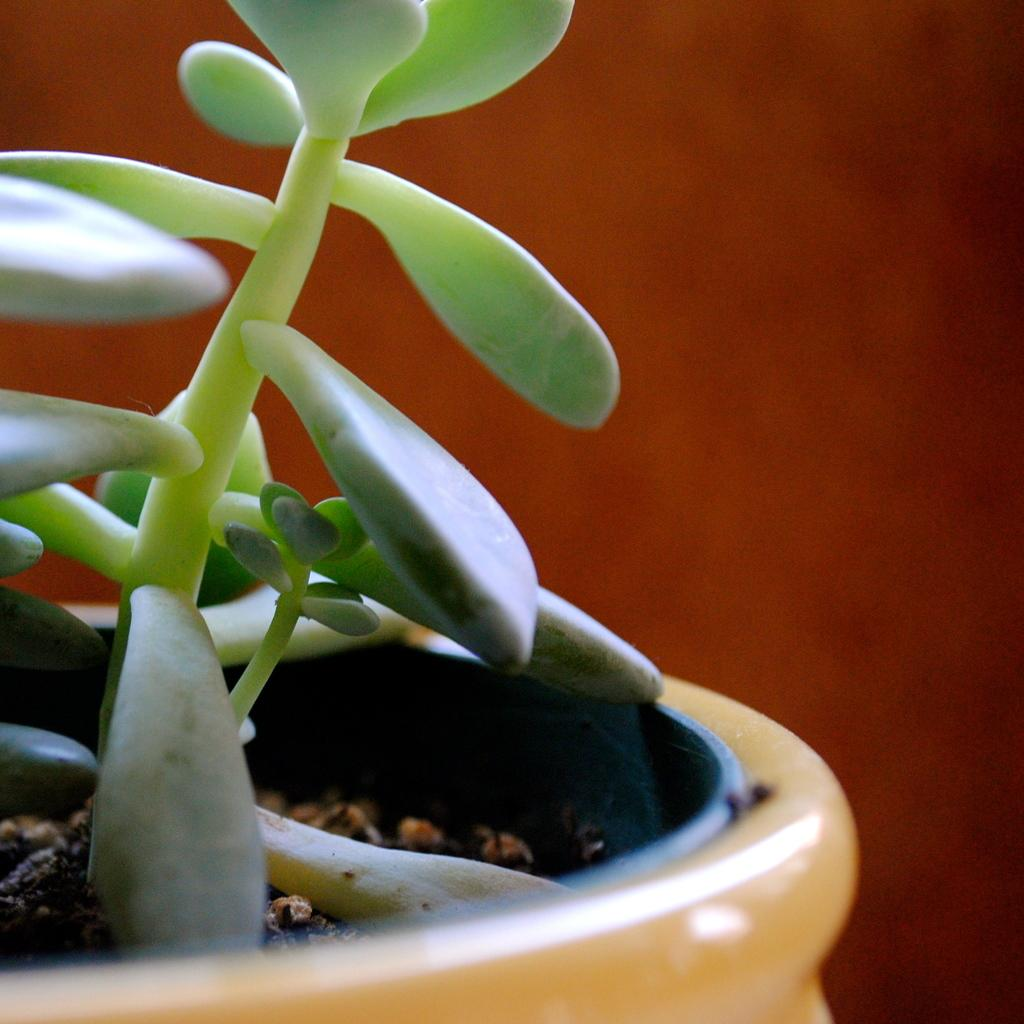What object is present in the image that holds a plant? There is a flower pot in the image that holds a plant. Can you describe the plant in the image? The image contains a plant, but no specific details about the plant are provided. What color is the background of the image? The background of the image has a red color. What type of thrill can be experienced by the bird in the image? There is no bird present in the image, so it is not possible to determine what type of thrill might be experienced. What is the purpose of the bomb in the image? There is no bomb present in the image, so it is not possible to determine its purpose. 